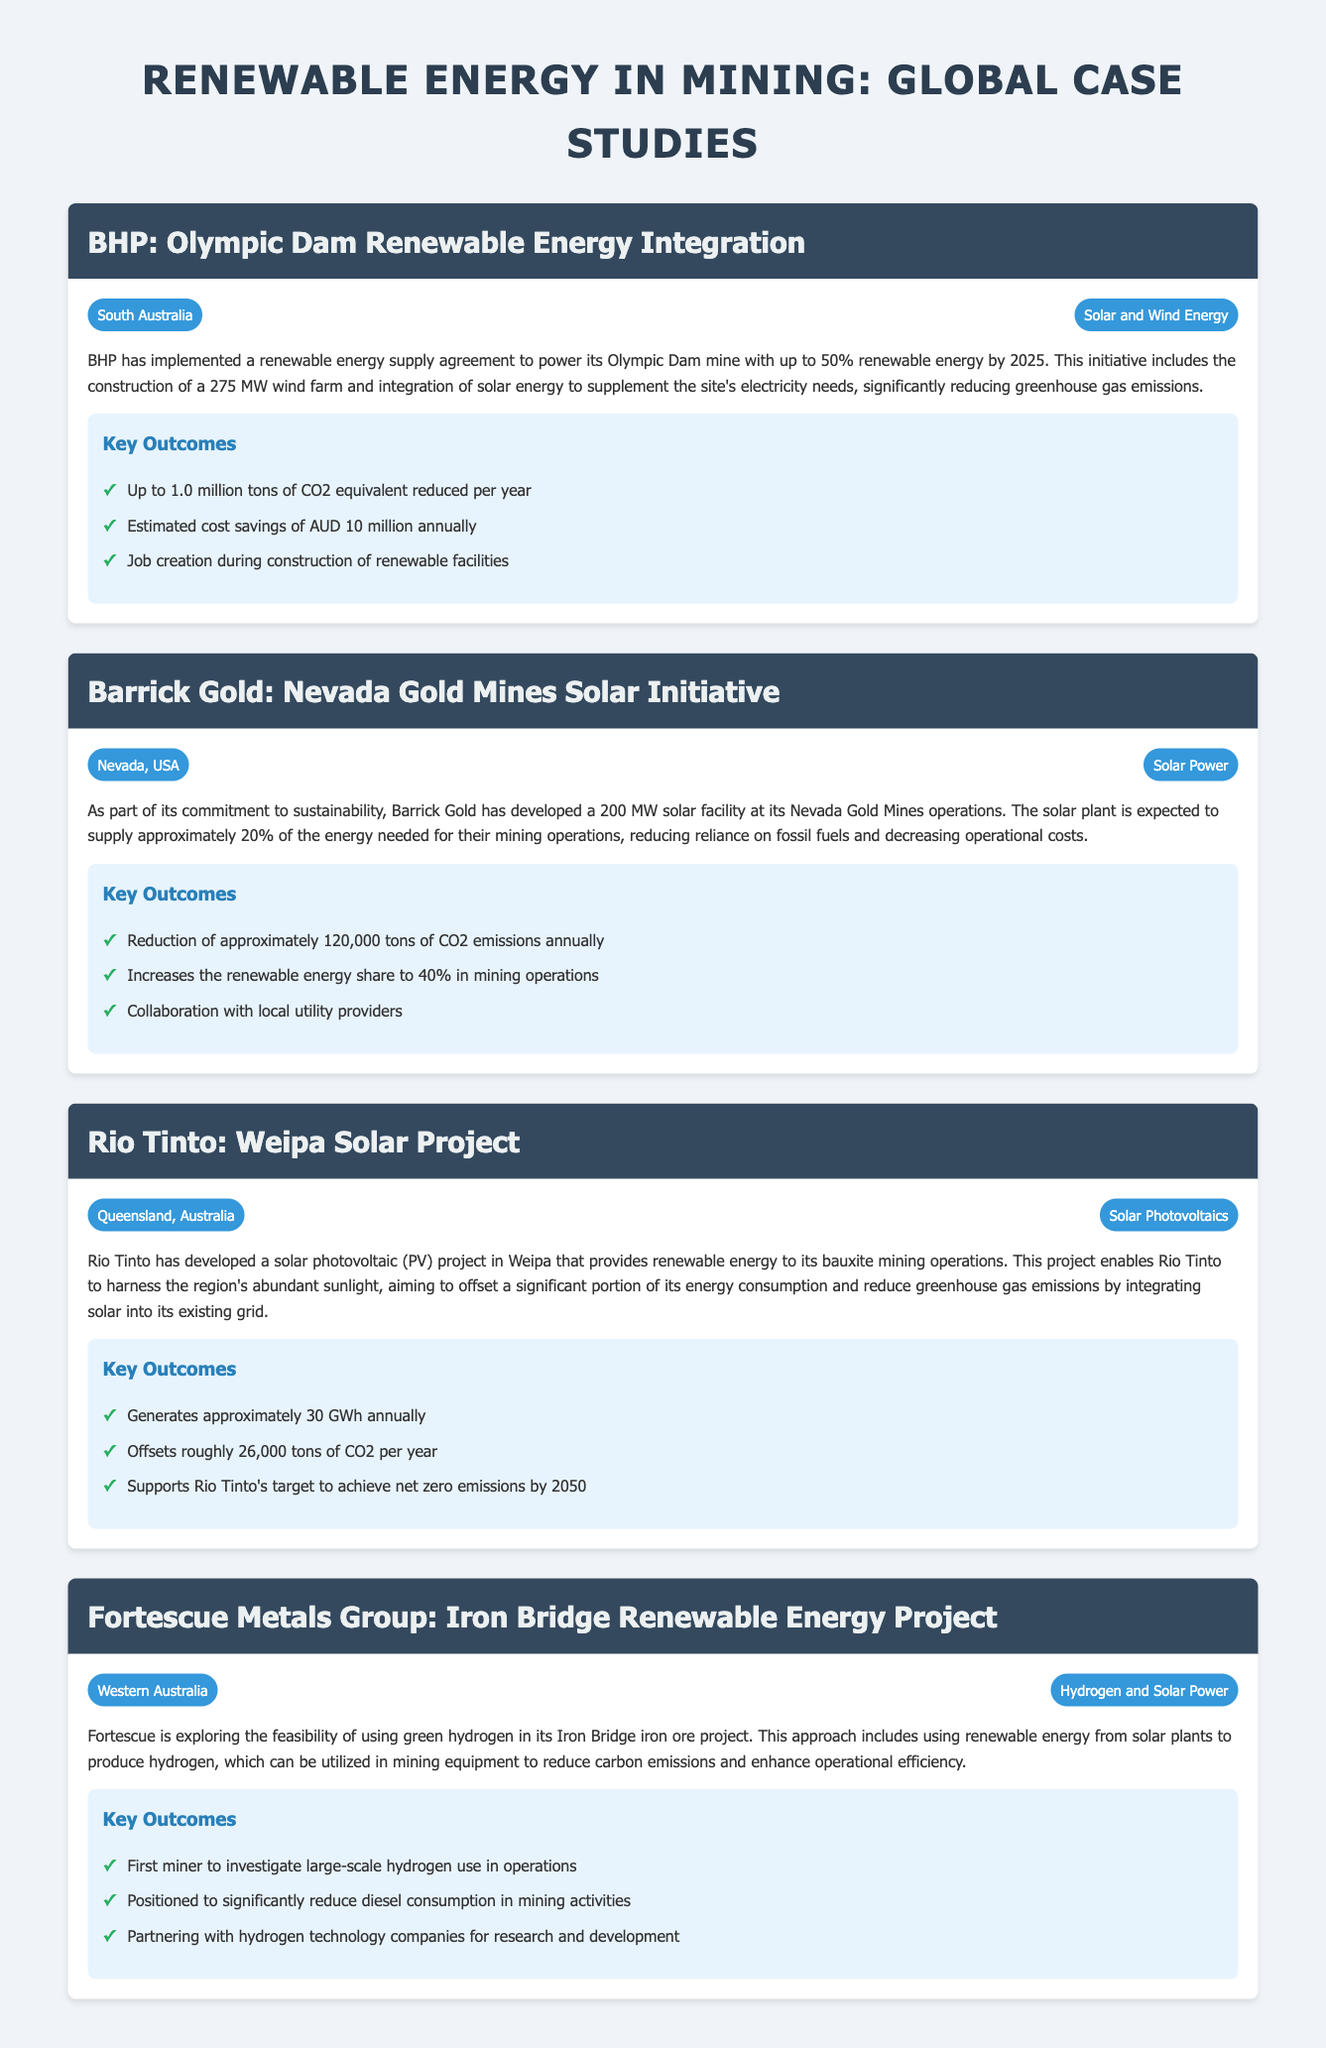What is the name of BHP's renewable energy project? The name of BHP's renewable energy project is "Olympic Dam Renewable Energy Integration."
Answer: Olympic Dam Renewable Energy Integration Which technology does Barrick Gold's solar initiative primarily use? The primary technology used in Barrick Gold's solar initiative is solar power.
Answer: Solar Power How much CO2 emissions reduction is expected from Rio Tinto's Weipa Solar Project annually? Rio Tinto's Weipa Solar Project is expected to reduce CO2 emissions by approximately 26,000 tons annually.
Answer: 26,000 tons What is the estimated annual cost savings for BHP from its renewable energy integration? The estimated annual cost savings for BHP from its renewable energy integration is AUD 10 million.
Answer: AUD 10 million In which region is Fortescue Metals Group's Iron Bridge Renewable Energy Project located? Fortescue Metals Group's Iron Bridge Renewable Energy Project is located in Western Australia.
Answer: Western Australia What percentage of energy will Barrick Gold's solar facility supply to its mining operations? Barrick Gold's solar facility will supply approximately 20% of the energy needed for their mining operations.
Answer: 20% What key outcome involves job creation in BHP's case study? The key outcome involving job creation in BHP's case study is during the construction of renewable facilities.
Answer: Job creation during construction What innovative technology is Fortescue exploring in its Iron Bridge project? Fortescue is exploring the use of green hydrogen in its Iron Bridge project.
Answer: Green hydrogen How much energy does Rio Tinto's solar project generate annually? Rio Tinto's solar project generates approximately 30 GWh annually.
Answer: 30 GWh 